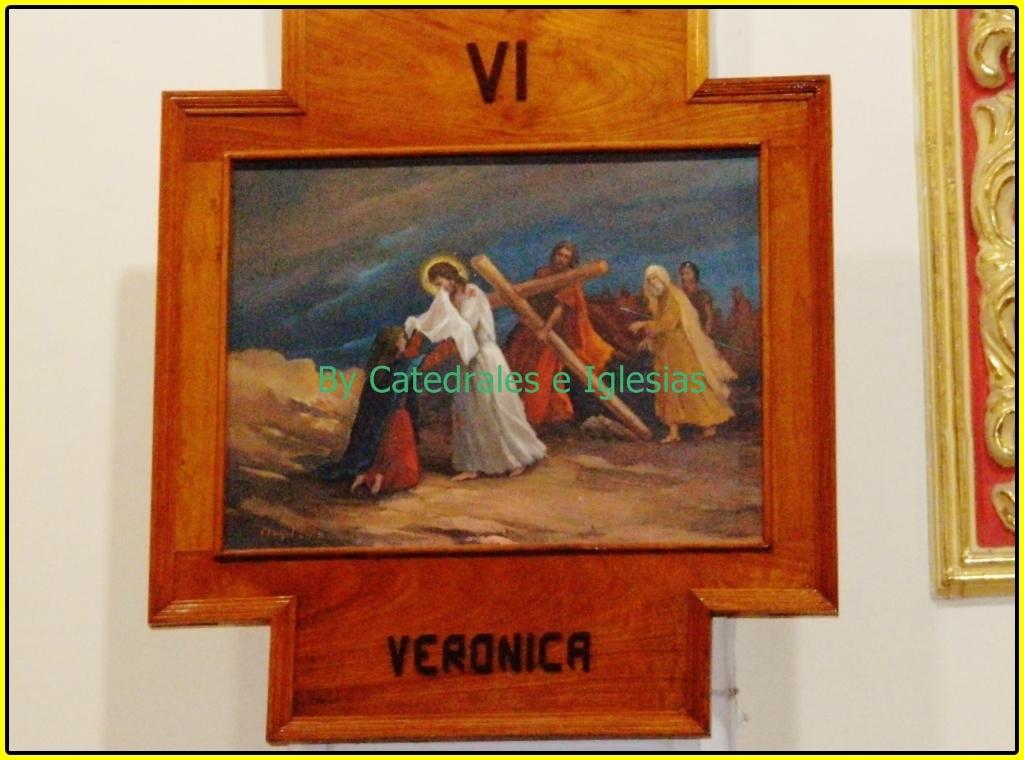What name is embellished at the bottom?
Keep it short and to the point. Veronica. Which two letters are on the top of the frame?
Keep it short and to the point. Vi. 